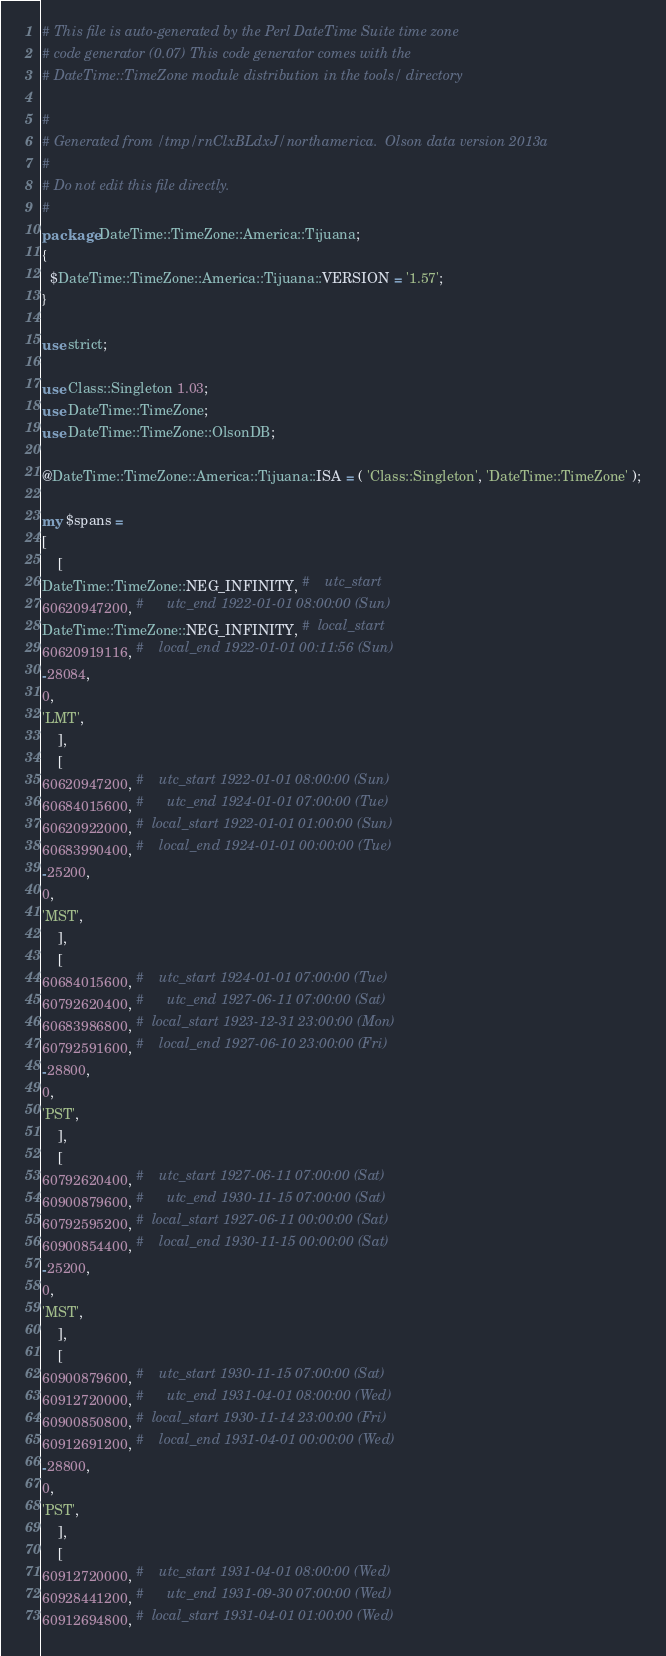<code> <loc_0><loc_0><loc_500><loc_500><_Perl_># This file is auto-generated by the Perl DateTime Suite time zone
# code generator (0.07) This code generator comes with the
# DateTime::TimeZone module distribution in the tools/ directory

#
# Generated from /tmp/rnClxBLdxJ/northamerica.  Olson data version 2013a
#
# Do not edit this file directly.
#
package DateTime::TimeZone::America::Tijuana;
{
  $DateTime::TimeZone::America::Tijuana::VERSION = '1.57';
}

use strict;

use Class::Singleton 1.03;
use DateTime::TimeZone;
use DateTime::TimeZone::OlsonDB;

@DateTime::TimeZone::America::Tijuana::ISA = ( 'Class::Singleton', 'DateTime::TimeZone' );

my $spans =
[
    [
DateTime::TimeZone::NEG_INFINITY, #    utc_start
60620947200, #      utc_end 1922-01-01 08:00:00 (Sun)
DateTime::TimeZone::NEG_INFINITY, #  local_start
60620919116, #    local_end 1922-01-01 00:11:56 (Sun)
-28084,
0,
'LMT',
    ],
    [
60620947200, #    utc_start 1922-01-01 08:00:00 (Sun)
60684015600, #      utc_end 1924-01-01 07:00:00 (Tue)
60620922000, #  local_start 1922-01-01 01:00:00 (Sun)
60683990400, #    local_end 1924-01-01 00:00:00 (Tue)
-25200,
0,
'MST',
    ],
    [
60684015600, #    utc_start 1924-01-01 07:00:00 (Tue)
60792620400, #      utc_end 1927-06-11 07:00:00 (Sat)
60683986800, #  local_start 1923-12-31 23:00:00 (Mon)
60792591600, #    local_end 1927-06-10 23:00:00 (Fri)
-28800,
0,
'PST',
    ],
    [
60792620400, #    utc_start 1927-06-11 07:00:00 (Sat)
60900879600, #      utc_end 1930-11-15 07:00:00 (Sat)
60792595200, #  local_start 1927-06-11 00:00:00 (Sat)
60900854400, #    local_end 1930-11-15 00:00:00 (Sat)
-25200,
0,
'MST',
    ],
    [
60900879600, #    utc_start 1930-11-15 07:00:00 (Sat)
60912720000, #      utc_end 1931-04-01 08:00:00 (Wed)
60900850800, #  local_start 1930-11-14 23:00:00 (Fri)
60912691200, #    local_end 1931-04-01 00:00:00 (Wed)
-28800,
0,
'PST',
    ],
    [
60912720000, #    utc_start 1931-04-01 08:00:00 (Wed)
60928441200, #      utc_end 1931-09-30 07:00:00 (Wed)
60912694800, #  local_start 1931-04-01 01:00:00 (Wed)</code> 